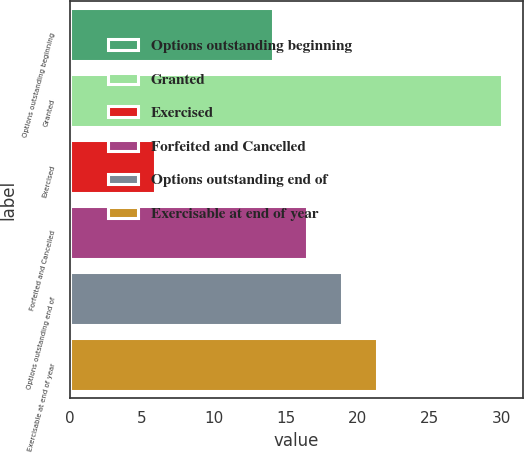Convert chart. <chart><loc_0><loc_0><loc_500><loc_500><bar_chart><fcel>Options outstanding beginning<fcel>Granted<fcel>Exercised<fcel>Forfeited and Cancelled<fcel>Options outstanding end of<fcel>Exercisable at end of year<nl><fcel>14.1<fcel>30.01<fcel>5.91<fcel>16.51<fcel>18.92<fcel>21.33<nl></chart> 